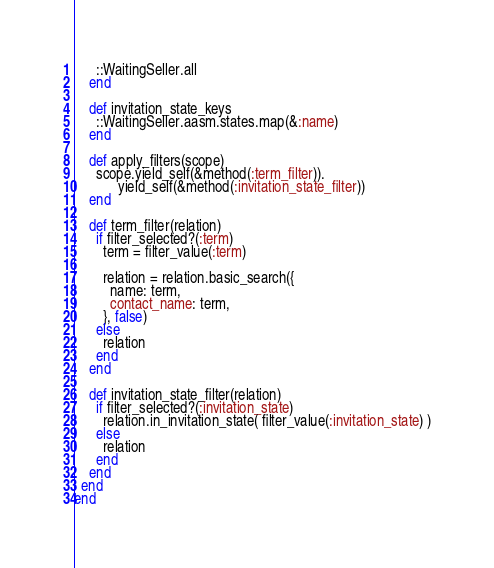<code> <loc_0><loc_0><loc_500><loc_500><_Ruby_>      ::WaitingSeller.all
    end

    def invitation_state_keys
      ::WaitingSeller.aasm.states.map(&:name)
    end

    def apply_filters(scope)
      scope.yield_self(&method(:term_filter)).
            yield_self(&method(:invitation_state_filter))
    end

    def term_filter(relation)
      if filter_selected?(:term)
        term = filter_value(:term)

        relation = relation.basic_search({
          name: term,
          contact_name: term,
        }, false)
      else
        relation
      end
    end

    def invitation_state_filter(relation)
      if filter_selected?(:invitation_state)
        relation.in_invitation_state( filter_value(:invitation_state) )
      else
        relation
      end
    end
  end
end
</code> 